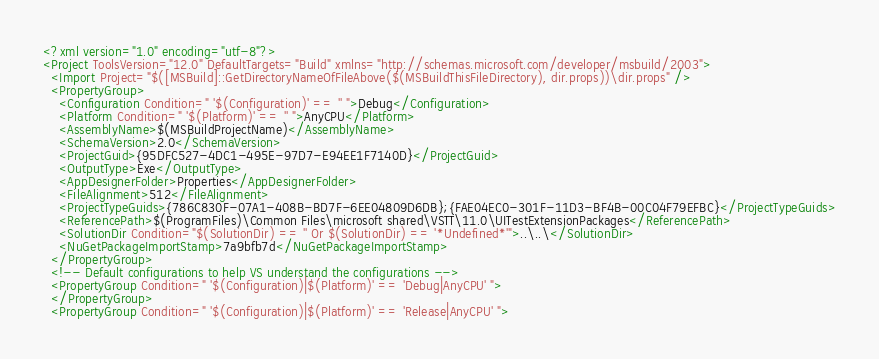<code> <loc_0><loc_0><loc_500><loc_500><_XML_><?xml version="1.0" encoding="utf-8"?>
<Project ToolsVersion="12.0" DefaultTargets="Build" xmlns="http://schemas.microsoft.com/developer/msbuild/2003">
  <Import Project="$([MSBuild]::GetDirectoryNameOfFileAbove($(MSBuildThisFileDirectory), dir.props))\dir.props" />
  <PropertyGroup>
    <Configuration Condition=" '$(Configuration)' == '' ">Debug</Configuration>
    <Platform Condition=" '$(Platform)' == '' ">AnyCPU</Platform>
    <AssemblyName>$(MSBuildProjectName)</AssemblyName>
    <SchemaVersion>2.0</SchemaVersion>
    <ProjectGuid>{95DFC527-4DC1-495E-97D7-E94EE1F7140D}</ProjectGuid>
    <OutputType>Exe</OutputType>
    <AppDesignerFolder>Properties</AppDesignerFolder>
    <FileAlignment>512</FileAlignment>
    <ProjectTypeGuids>{786C830F-07A1-408B-BD7F-6EE04809D6DB};{FAE04EC0-301F-11D3-BF4B-00C04F79EFBC}</ProjectTypeGuids>
    <ReferencePath>$(ProgramFiles)\Common Files\microsoft shared\VSTT\11.0\UITestExtensionPackages</ReferencePath>
    <SolutionDir Condition="$(SolutionDir) == '' Or $(SolutionDir) == '*Undefined*'">..\..\</SolutionDir>
    <NuGetPackageImportStamp>7a9bfb7d</NuGetPackageImportStamp>
  </PropertyGroup>
  <!-- Default configurations to help VS understand the configurations -->
  <PropertyGroup Condition=" '$(Configuration)|$(Platform)' == 'Debug|AnyCPU' ">
  </PropertyGroup>
  <PropertyGroup Condition=" '$(Configuration)|$(Platform)' == 'Release|AnyCPU' "></code> 